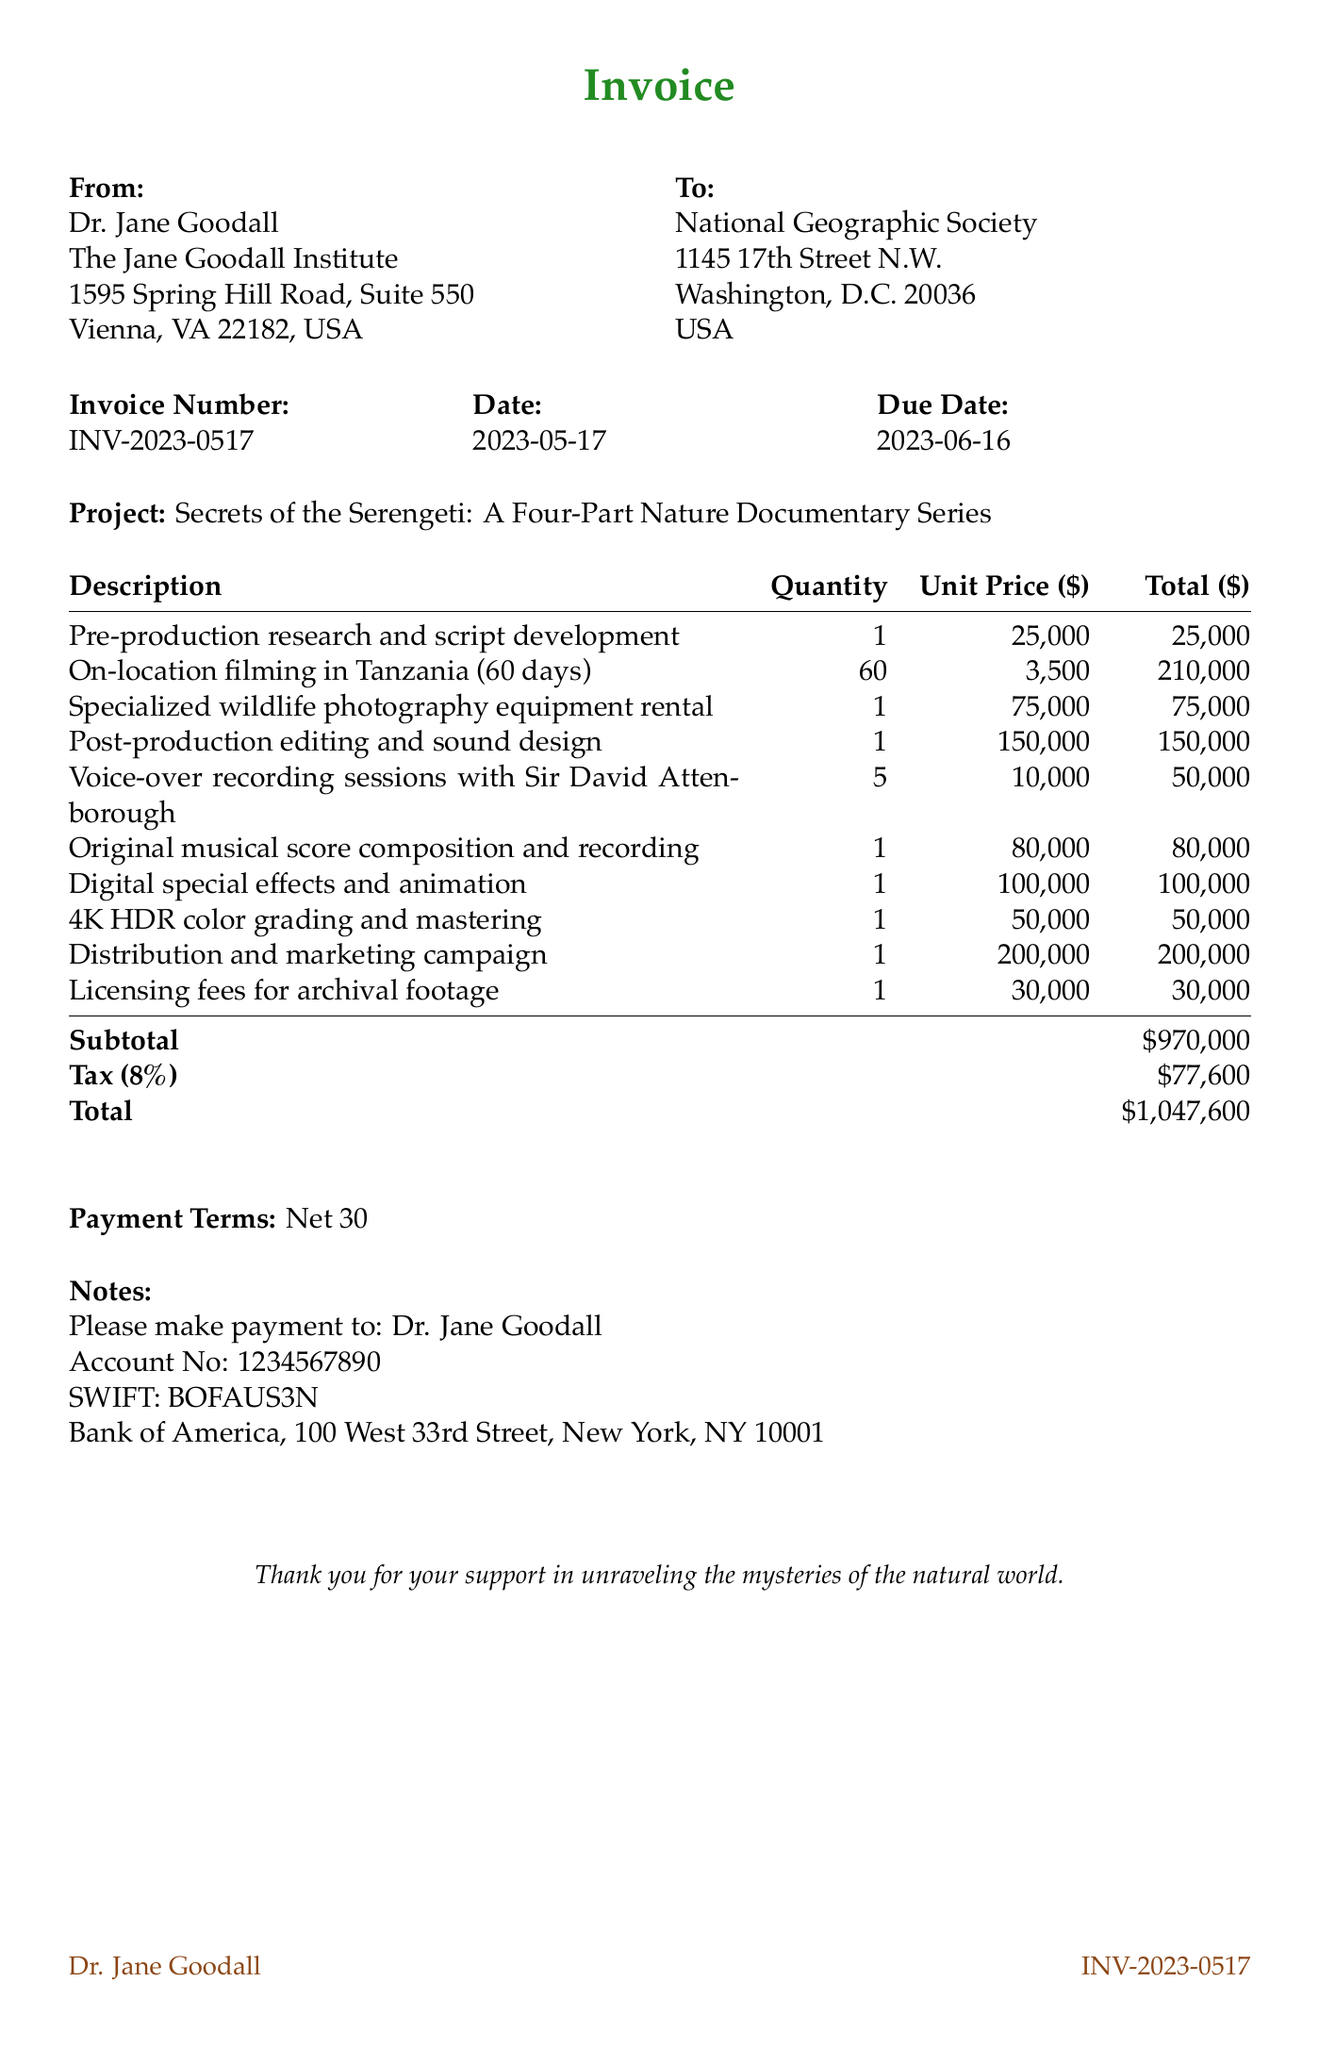What is the invoice number? The invoice number is provided at the top of the document, allowing easy reference to this specific invoice.
Answer: INV-2023-0517 Who is the client for this invoice? The client’s name is noted prominently in the document, indicating whom the invoice is addressed to.
Answer: National Geographic Society What is the total amount due? The total amount due summarizes the subtotal plus any applicable taxes, which is a key piece of financial information.
Answer: 1,047,600 How many days was the on-location filming conducted? The document specifies the duration for the filming as part of the services provided, giving insight into the extent of the project.
Answer: 60 days What is the tax rate applied on the invoice? The tax rate is mentioned explicitly, which informs the client of the additional charges based on the subtotal.
Answer: 8% Who is the voice-over artist for the documentary? The document includes details about the talent involved, which can be an important aspect of the project’s production quality.
Answer: Sir David Attenborough What services are included in the post-production phase? The services included in the post-production phase are described in the invoice, highlighting the essential components of this stage.
Answer: Editing and sound design What is the due date for payment? The due date is critical for the client to assure timely payment, which is stated clearly.
Answer: 2023-06-16 What does "Net 30" indicate? The payment terms clarify when the payment is expected relative to the invoice date, which is standard for business transactions.
Answer: Payment due in 30 days 